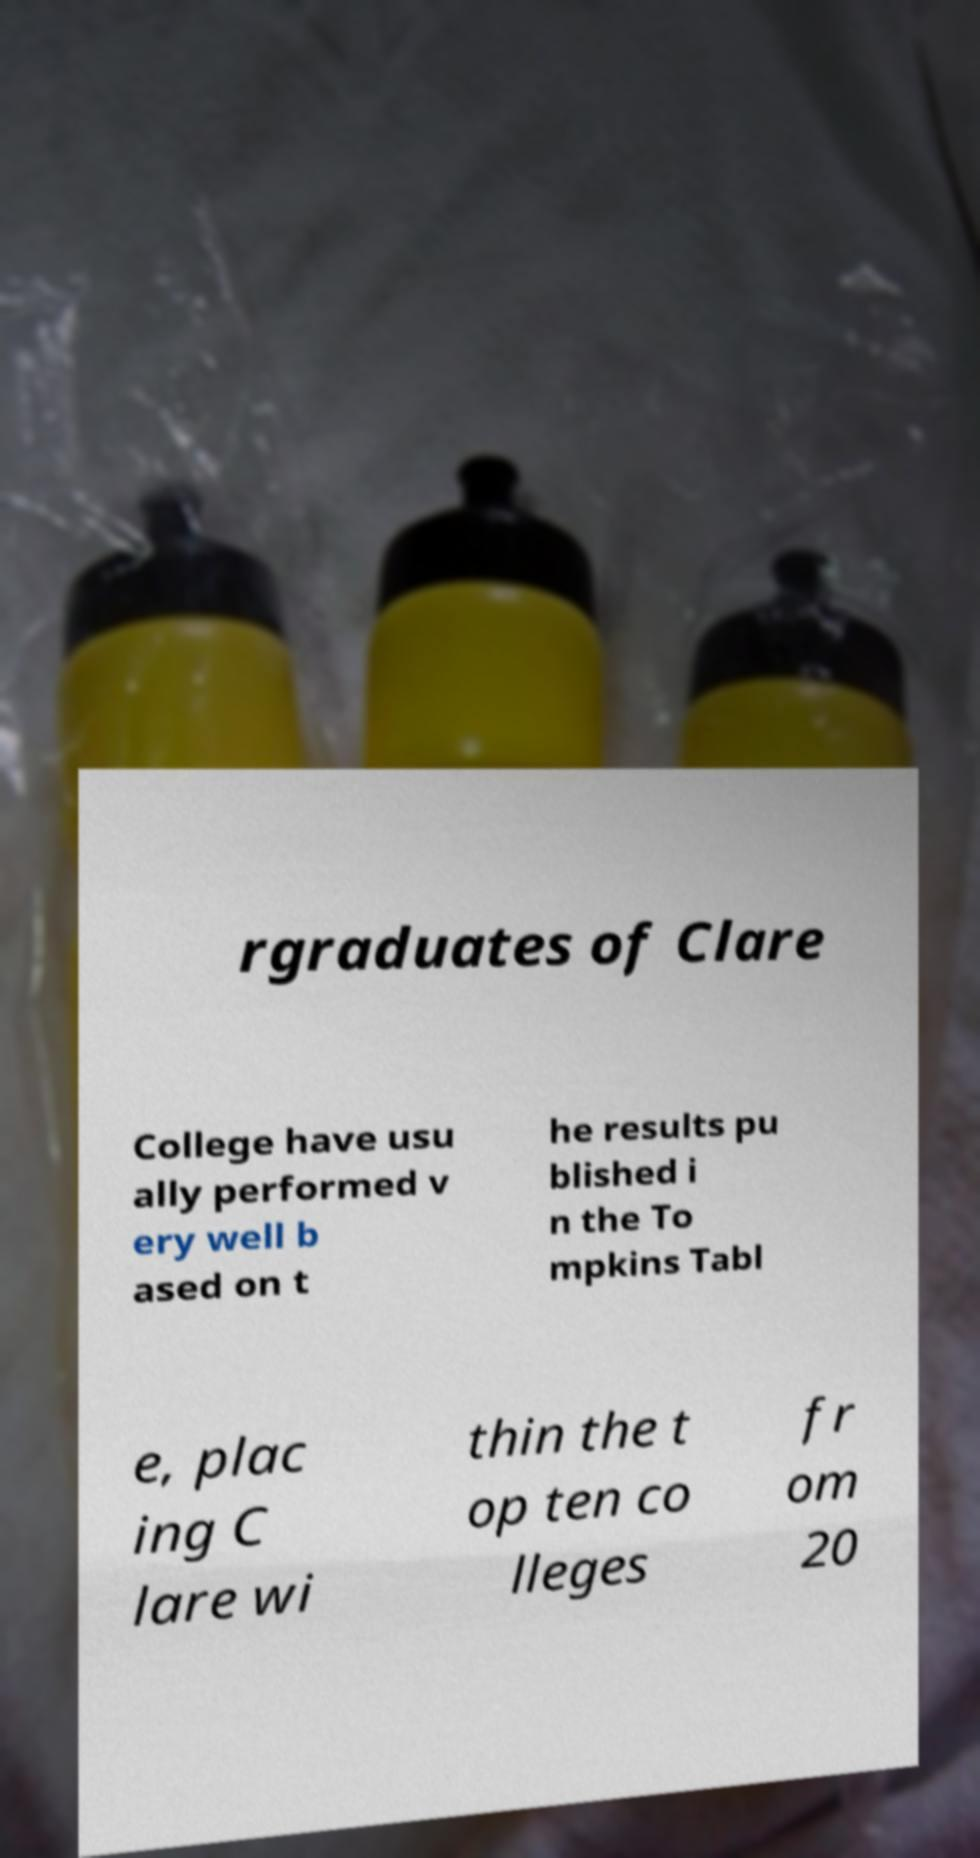Could you assist in decoding the text presented in this image and type it out clearly? rgraduates of Clare College have usu ally performed v ery well b ased on t he results pu blished i n the To mpkins Tabl e, plac ing C lare wi thin the t op ten co lleges fr om 20 